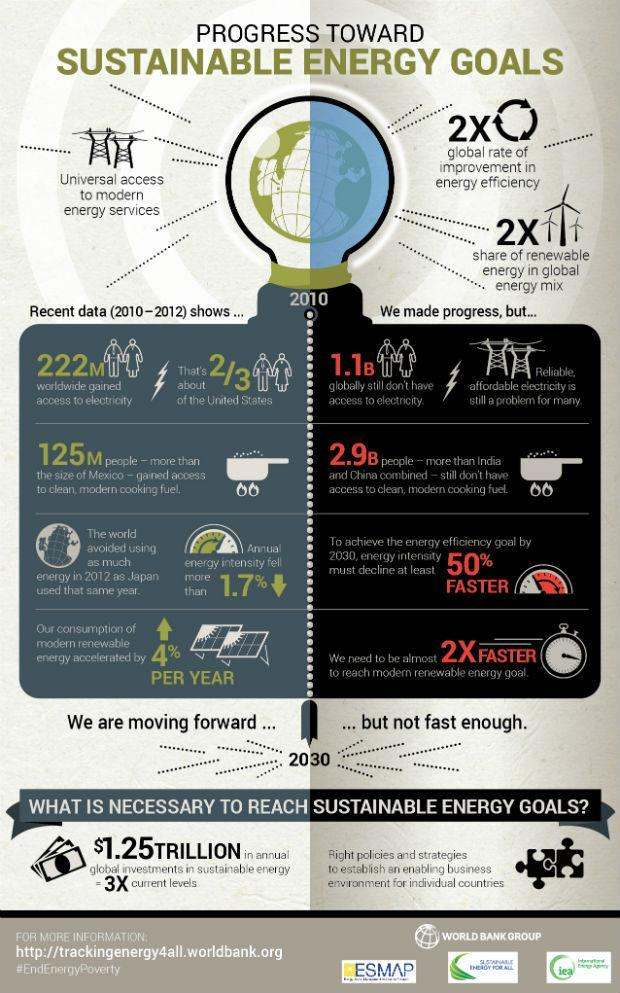What is the percentage increase in the consumption of modern renewable energy per year?
Answer the question with a short phrase. 4% What population in the world do not have access to electricity? 1.1B 